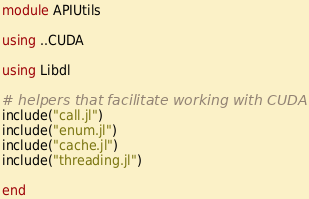Convert code to text. <code><loc_0><loc_0><loc_500><loc_500><_Julia_>module APIUtils

using ..CUDA

using Libdl

# helpers that facilitate working with CUDA APIs
include("call.jl")
include("enum.jl")
include("cache.jl")
include("threading.jl")

end
</code> 